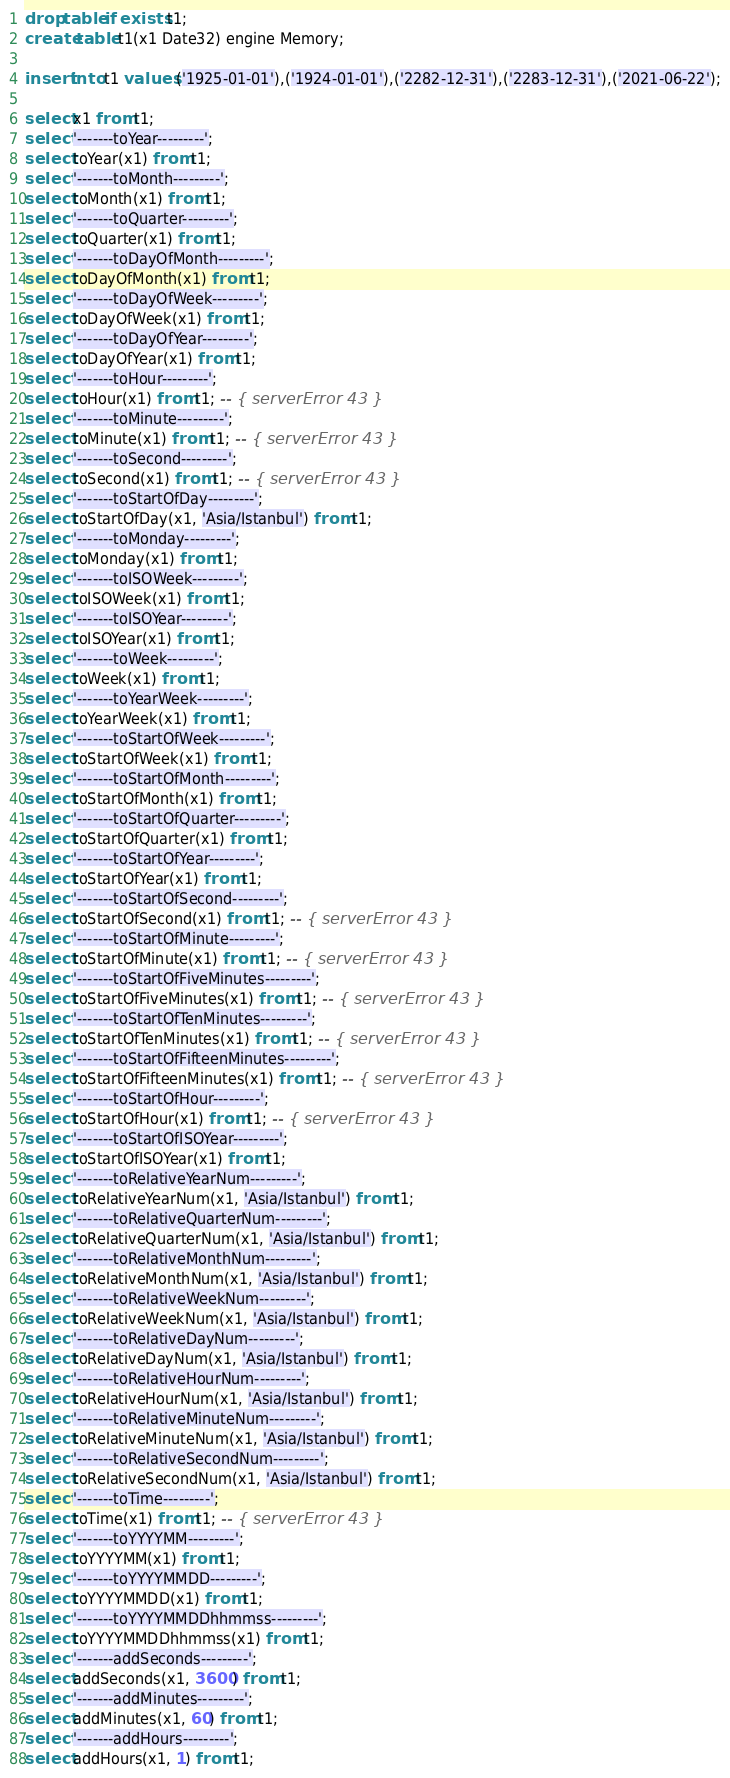<code> <loc_0><loc_0><loc_500><loc_500><_SQL_>drop table if exists t1;
create table t1(x1 Date32) engine Memory;

insert into t1 values ('1925-01-01'),('1924-01-01'),('2282-12-31'),('2283-12-31'),('2021-06-22');

select x1 from t1;
select '-------toYear---------';
select toYear(x1) from t1;
select '-------toMonth---------';
select toMonth(x1) from t1;
select '-------toQuarter---------';
select toQuarter(x1) from t1;
select '-------toDayOfMonth---------';
select toDayOfMonth(x1) from t1;
select '-------toDayOfWeek---------';
select toDayOfWeek(x1) from t1;
select '-------toDayOfYear---------';
select toDayOfYear(x1) from t1;
select '-------toHour---------';
select toHour(x1) from t1; -- { serverError 43 }
select '-------toMinute---------';
select toMinute(x1) from t1; -- { serverError 43 }
select '-------toSecond---------';
select toSecond(x1) from t1; -- { serverError 43 }
select '-------toStartOfDay---------';
select toStartOfDay(x1, 'Asia/Istanbul') from t1;
select '-------toMonday---------';
select toMonday(x1) from t1;
select '-------toISOWeek---------';
select toISOWeek(x1) from t1;
select '-------toISOYear---------';
select toISOYear(x1) from t1;
select '-------toWeek---------';
select toWeek(x1) from t1;
select '-------toYearWeek---------';
select toYearWeek(x1) from t1;
select '-------toStartOfWeek---------';
select toStartOfWeek(x1) from t1;
select '-------toStartOfMonth---------';
select toStartOfMonth(x1) from t1;
select '-------toStartOfQuarter---------';
select toStartOfQuarter(x1) from t1;
select '-------toStartOfYear---------';
select toStartOfYear(x1) from t1;
select '-------toStartOfSecond---------';
select toStartOfSecond(x1) from t1; -- { serverError 43 }
select '-------toStartOfMinute---------';
select toStartOfMinute(x1) from t1; -- { serverError 43 }
select '-------toStartOfFiveMinutes---------';
select toStartOfFiveMinutes(x1) from t1; -- { serverError 43 }
select '-------toStartOfTenMinutes---------';
select toStartOfTenMinutes(x1) from t1; -- { serverError 43 }
select '-------toStartOfFifteenMinutes---------';
select toStartOfFifteenMinutes(x1) from t1; -- { serverError 43 }
select '-------toStartOfHour---------';
select toStartOfHour(x1) from t1; -- { serverError 43 }
select '-------toStartOfISOYear---------';
select toStartOfISOYear(x1) from t1;
select '-------toRelativeYearNum---------';
select toRelativeYearNum(x1, 'Asia/Istanbul') from t1;
select '-------toRelativeQuarterNum---------';
select toRelativeQuarterNum(x1, 'Asia/Istanbul') from t1;
select '-------toRelativeMonthNum---------';
select toRelativeMonthNum(x1, 'Asia/Istanbul') from t1;
select '-------toRelativeWeekNum---------';
select toRelativeWeekNum(x1, 'Asia/Istanbul') from t1;
select '-------toRelativeDayNum---------';
select toRelativeDayNum(x1, 'Asia/Istanbul') from t1;
select '-------toRelativeHourNum---------';
select toRelativeHourNum(x1, 'Asia/Istanbul') from t1;
select '-------toRelativeMinuteNum---------';
select toRelativeMinuteNum(x1, 'Asia/Istanbul') from t1;
select '-------toRelativeSecondNum---------';
select toRelativeSecondNum(x1, 'Asia/Istanbul') from t1;
select '-------toTime---------';
select toTime(x1) from t1; -- { serverError 43 }
select '-------toYYYYMM---------';
select toYYYYMM(x1) from t1;
select '-------toYYYYMMDD---------';
select toYYYYMMDD(x1) from t1;
select '-------toYYYYMMDDhhmmss---------';
select toYYYYMMDDhhmmss(x1) from t1;
select '-------addSeconds---------';
select addSeconds(x1, 3600) from t1;
select '-------addMinutes---------';
select addMinutes(x1, 60) from t1;
select '-------addHours---------';
select addHours(x1, 1) from t1;</code> 